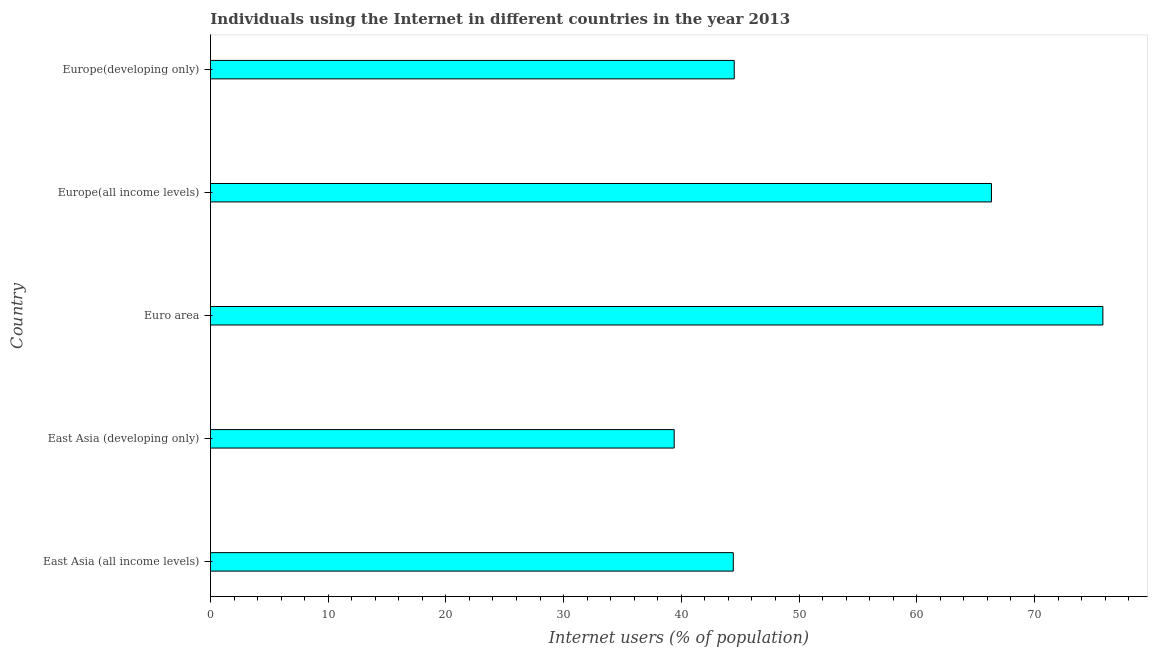Does the graph contain grids?
Your answer should be compact. No. What is the title of the graph?
Keep it short and to the point. Individuals using the Internet in different countries in the year 2013. What is the label or title of the X-axis?
Your answer should be compact. Internet users (% of population). What is the label or title of the Y-axis?
Your response must be concise. Country. What is the number of internet users in East Asia (all income levels)?
Your answer should be compact. 44.41. Across all countries, what is the maximum number of internet users?
Give a very brief answer. 75.81. Across all countries, what is the minimum number of internet users?
Keep it short and to the point. 39.39. In which country was the number of internet users minimum?
Offer a terse response. East Asia (developing only). What is the sum of the number of internet users?
Offer a very short reply. 270.45. What is the difference between the number of internet users in Euro area and Europe(developing only)?
Offer a very short reply. 31.32. What is the average number of internet users per country?
Provide a short and direct response. 54.09. What is the median number of internet users?
Give a very brief answer. 44.49. In how many countries, is the number of internet users greater than 70 %?
Provide a short and direct response. 1. What is the ratio of the number of internet users in Europe(all income levels) to that in Europe(developing only)?
Provide a short and direct response. 1.49. Is the difference between the number of internet users in Euro area and Europe(developing only) greater than the difference between any two countries?
Give a very brief answer. No. What is the difference between the highest and the second highest number of internet users?
Offer a terse response. 9.47. Is the sum of the number of internet users in East Asia (all income levels) and Euro area greater than the maximum number of internet users across all countries?
Your response must be concise. Yes. What is the difference between the highest and the lowest number of internet users?
Your response must be concise. 36.42. How many bars are there?
Offer a very short reply. 5. How many countries are there in the graph?
Your answer should be very brief. 5. What is the Internet users (% of population) of East Asia (all income levels)?
Ensure brevity in your answer.  44.41. What is the Internet users (% of population) in East Asia (developing only)?
Provide a succinct answer. 39.39. What is the Internet users (% of population) of Euro area?
Provide a short and direct response. 75.81. What is the Internet users (% of population) of Europe(all income levels)?
Your response must be concise. 66.34. What is the Internet users (% of population) of Europe(developing only)?
Ensure brevity in your answer.  44.49. What is the difference between the Internet users (% of population) in East Asia (all income levels) and East Asia (developing only)?
Offer a very short reply. 5.02. What is the difference between the Internet users (% of population) in East Asia (all income levels) and Euro area?
Provide a short and direct response. -31.4. What is the difference between the Internet users (% of population) in East Asia (all income levels) and Europe(all income levels)?
Give a very brief answer. -21.93. What is the difference between the Internet users (% of population) in East Asia (all income levels) and Europe(developing only)?
Offer a very short reply. -0.08. What is the difference between the Internet users (% of population) in East Asia (developing only) and Euro area?
Your response must be concise. -36.42. What is the difference between the Internet users (% of population) in East Asia (developing only) and Europe(all income levels)?
Your answer should be compact. -26.95. What is the difference between the Internet users (% of population) in East Asia (developing only) and Europe(developing only)?
Your answer should be compact. -5.1. What is the difference between the Internet users (% of population) in Euro area and Europe(all income levels)?
Keep it short and to the point. 9.47. What is the difference between the Internet users (% of population) in Euro area and Europe(developing only)?
Offer a very short reply. 31.32. What is the difference between the Internet users (% of population) in Europe(all income levels) and Europe(developing only)?
Offer a very short reply. 21.85. What is the ratio of the Internet users (% of population) in East Asia (all income levels) to that in East Asia (developing only)?
Your answer should be very brief. 1.13. What is the ratio of the Internet users (% of population) in East Asia (all income levels) to that in Euro area?
Give a very brief answer. 0.59. What is the ratio of the Internet users (% of population) in East Asia (all income levels) to that in Europe(all income levels)?
Give a very brief answer. 0.67. What is the ratio of the Internet users (% of population) in East Asia (developing only) to that in Euro area?
Your response must be concise. 0.52. What is the ratio of the Internet users (% of population) in East Asia (developing only) to that in Europe(all income levels)?
Provide a succinct answer. 0.59. What is the ratio of the Internet users (% of population) in East Asia (developing only) to that in Europe(developing only)?
Your answer should be very brief. 0.89. What is the ratio of the Internet users (% of population) in Euro area to that in Europe(all income levels)?
Provide a short and direct response. 1.14. What is the ratio of the Internet users (% of population) in Euro area to that in Europe(developing only)?
Keep it short and to the point. 1.7. What is the ratio of the Internet users (% of population) in Europe(all income levels) to that in Europe(developing only)?
Ensure brevity in your answer.  1.49. 